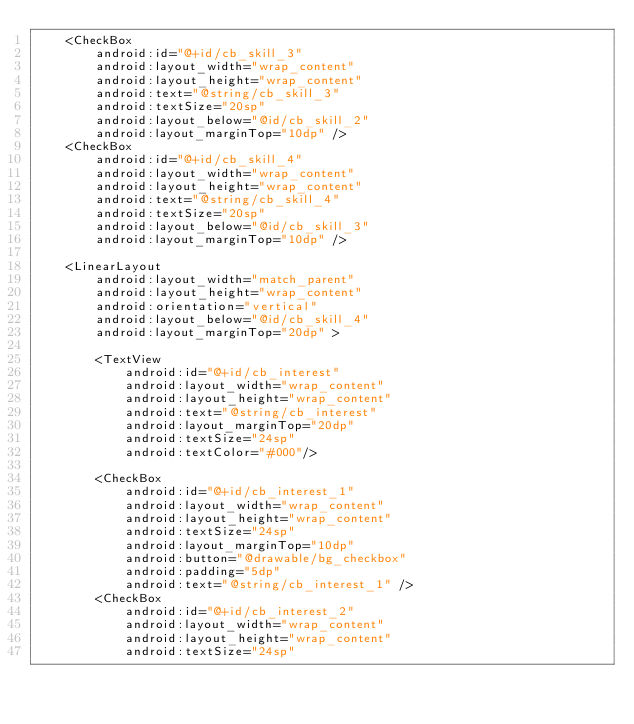Convert code to text. <code><loc_0><loc_0><loc_500><loc_500><_XML_>    <CheckBox
        android:id="@+id/cb_skill_3"
        android:layout_width="wrap_content"
        android:layout_height="wrap_content"
        android:text="@string/cb_skill_3"
        android:textSize="20sp"
        android:layout_below="@id/cb_skill_2"
        android:layout_marginTop="10dp" />
    <CheckBox
        android:id="@+id/cb_skill_4"
        android:layout_width="wrap_content"
        android:layout_height="wrap_content"
        android:text="@string/cb_skill_4"
        android:textSize="20sp"
        android:layout_below="@id/cb_skill_3"
        android:layout_marginTop="10dp" />

    <LinearLayout
        android:layout_width="match_parent"
        android:layout_height="wrap_content"
        android:orientation="vertical"
        android:layout_below="@id/cb_skill_4"
        android:layout_marginTop="20dp" >

        <TextView
            android:id="@+id/cb_interest"
            android:layout_width="wrap_content"
            android:layout_height="wrap_content"
            android:text="@string/cb_interest"
            android:layout_marginTop="20dp"
            android:textSize="24sp"
            android:textColor="#000"/>

        <CheckBox
            android:id="@+id/cb_interest_1"
            android:layout_width="wrap_content"
            android:layout_height="wrap_content"
            android:textSize="24sp"
            android:layout_marginTop="10dp"
            android:button="@drawable/bg_checkbox"
            android:padding="5dp"
            android:text="@string/cb_interest_1" />
        <CheckBox
            android:id="@+id/cb_interest_2"
            android:layout_width="wrap_content"
            android:layout_height="wrap_content"
            android:textSize="24sp"</code> 